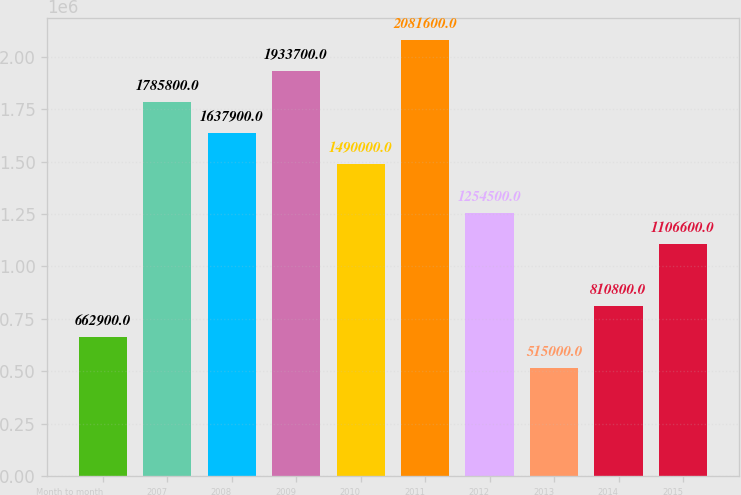Convert chart. <chart><loc_0><loc_0><loc_500><loc_500><bar_chart><fcel>Month to month<fcel>2007<fcel>2008<fcel>2009<fcel>2010<fcel>2011<fcel>2012<fcel>2013<fcel>2014<fcel>2015<nl><fcel>662900<fcel>1.7858e+06<fcel>1.6379e+06<fcel>1.9337e+06<fcel>1.49e+06<fcel>2.0816e+06<fcel>1.2545e+06<fcel>515000<fcel>810800<fcel>1.1066e+06<nl></chart> 